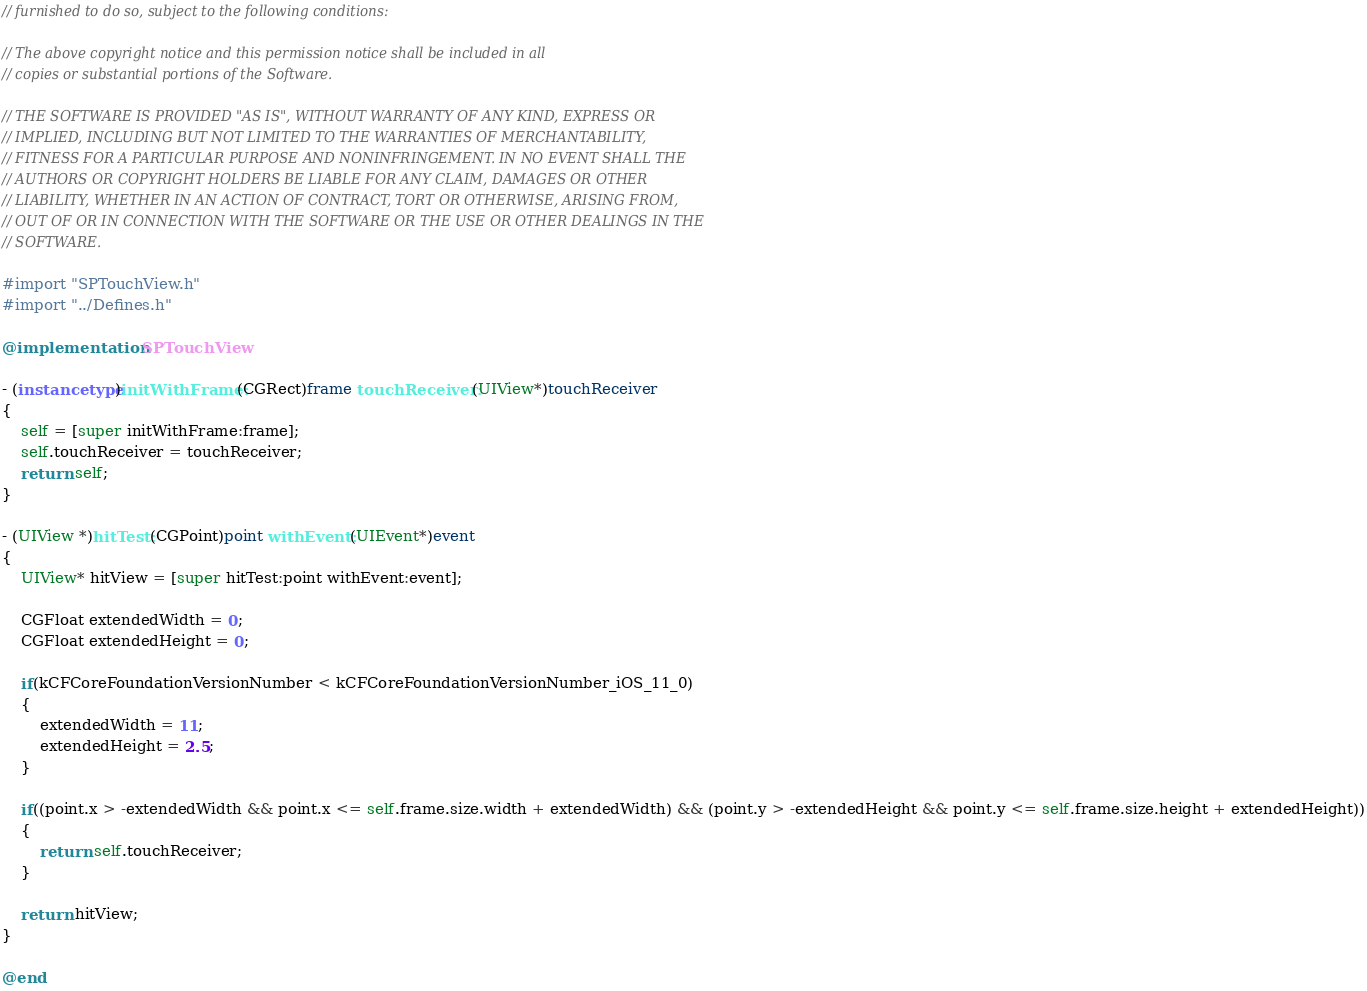<code> <loc_0><loc_0><loc_500><loc_500><_ObjectiveC_>// furnished to do so, subject to the following conditions:

// The above copyright notice and this permission notice shall be included in all
// copies or substantial portions of the Software.

// THE SOFTWARE IS PROVIDED "AS IS", WITHOUT WARRANTY OF ANY KIND, EXPRESS OR
// IMPLIED, INCLUDING BUT NOT LIMITED TO THE WARRANTIES OF MERCHANTABILITY,
// FITNESS FOR A PARTICULAR PURPOSE AND NONINFRINGEMENT. IN NO EVENT SHALL THE
// AUTHORS OR COPYRIGHT HOLDERS BE LIABLE FOR ANY CLAIM, DAMAGES OR OTHER
// LIABILITY, WHETHER IN AN ACTION OF CONTRACT, TORT OR OTHERWISE, ARISING FROM,
// OUT OF OR IN CONNECTION WITH THE SOFTWARE OR THE USE OR OTHER DEALINGS IN THE
// SOFTWARE.

#import "SPTouchView.h"
#import "../Defines.h"

@implementation SPTouchView

- (instancetype)initWithFrame:(CGRect)frame touchReceiver:(UIView*)touchReceiver
{
	self = [super initWithFrame:frame];
	self.touchReceiver = touchReceiver;
	return self;
}

- (UIView *)hitTest:(CGPoint)point withEvent:(UIEvent*)event
{
	UIView* hitView = [super hitTest:point withEvent:event];

	CGFloat extendedWidth = 0;
	CGFloat extendedHeight = 0;

	if(kCFCoreFoundationVersionNumber < kCFCoreFoundationVersionNumber_iOS_11_0)
	{
		extendedWidth = 11;
		extendedHeight = 2.5;
	}

	if((point.x > -extendedWidth && point.x <= self.frame.size.width + extendedWidth) && (point.y > -extendedHeight && point.y <= self.frame.size.height + extendedHeight))
	{
		return self.touchReceiver;
	}

	return hitView;
}

@end
</code> 